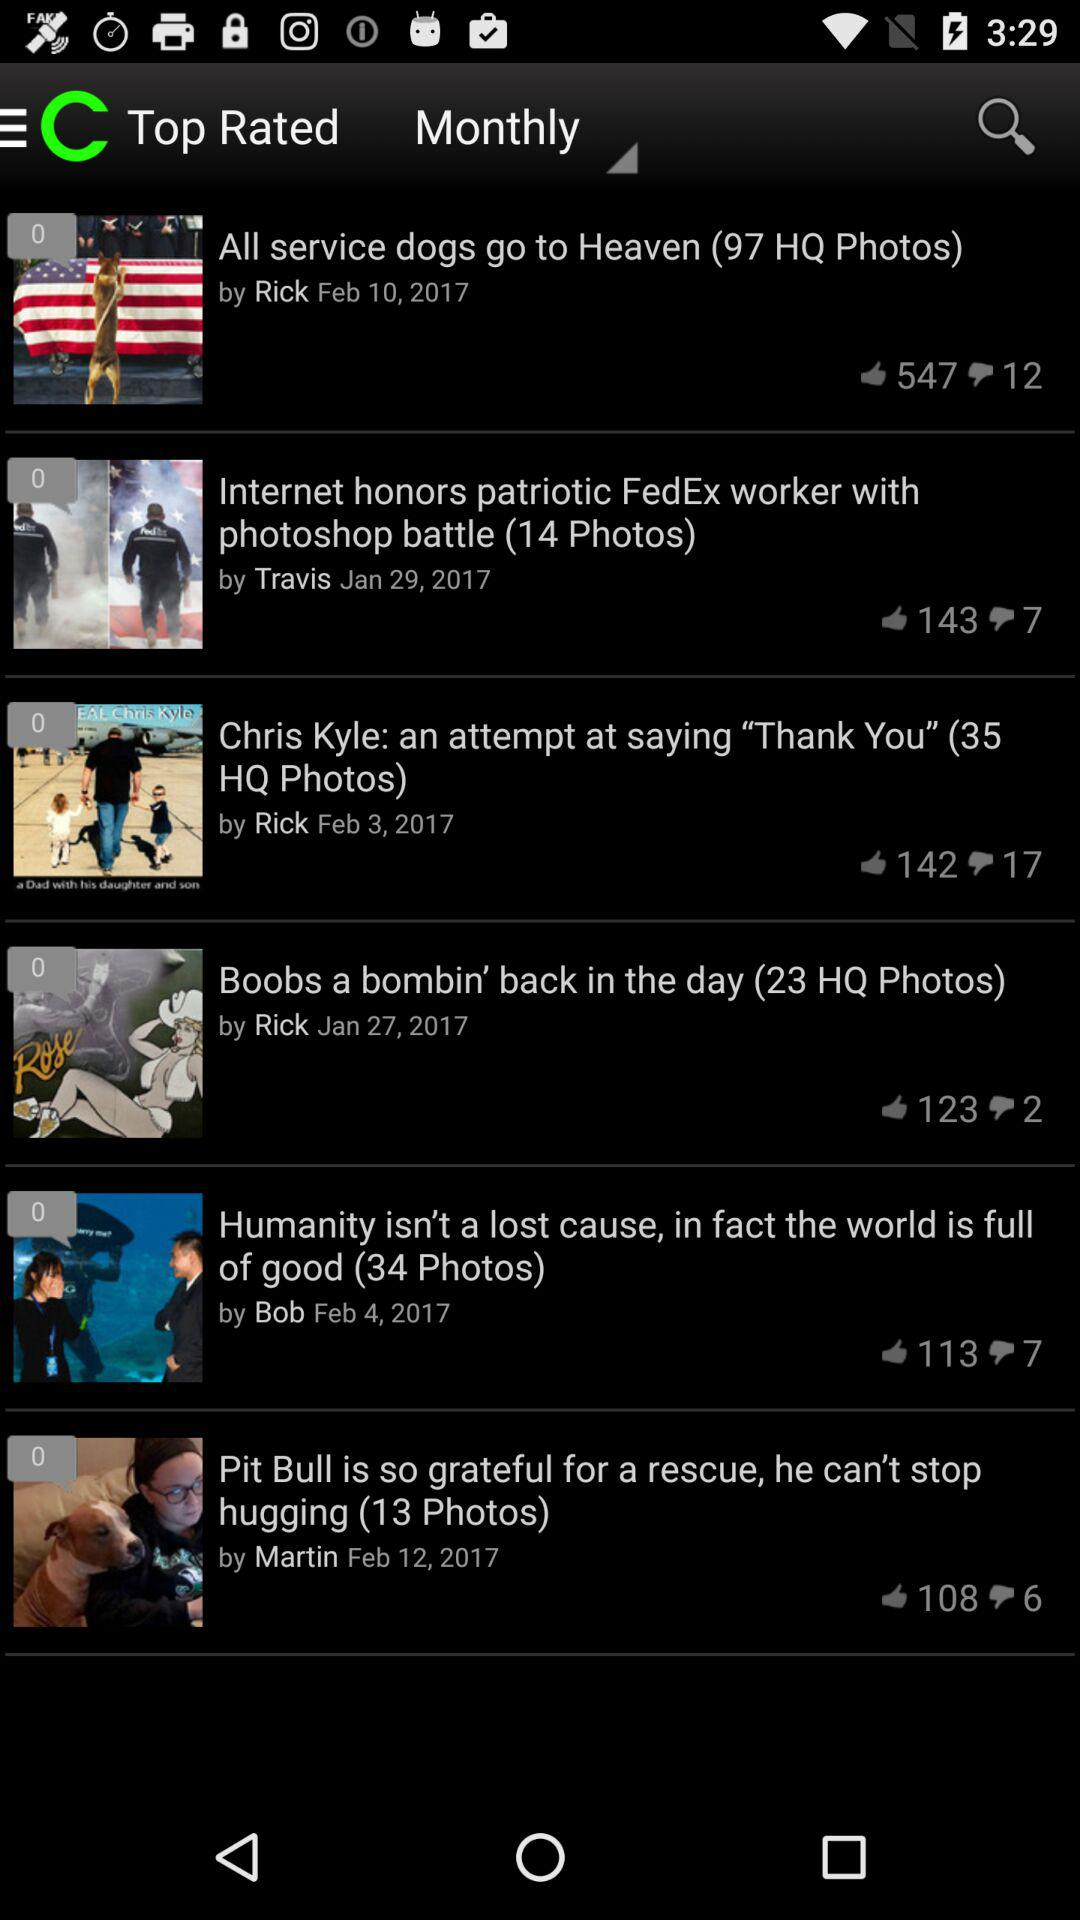By which sorting option is the news arranged? The sorting option is "Monthly". 